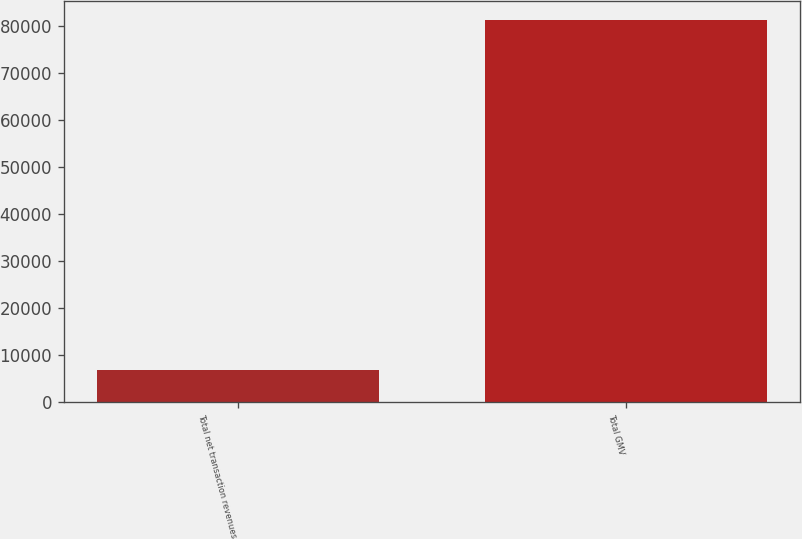<chart> <loc_0><loc_0><loc_500><loc_500><bar_chart><fcel>Total net transaction revenues<fcel>Total GMV<nl><fcel>6828<fcel>81304<nl></chart> 